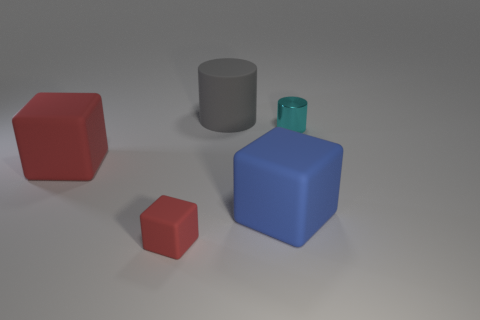Add 2 small yellow metallic cylinders. How many objects exist? 7 Subtract all cubes. How many objects are left? 2 Subtract 0 green blocks. How many objects are left? 5 Subtract all big gray things. Subtract all shiny cylinders. How many objects are left? 3 Add 4 tiny cyan cylinders. How many tiny cyan cylinders are left? 5 Add 4 brown metal things. How many brown metal things exist? 4 